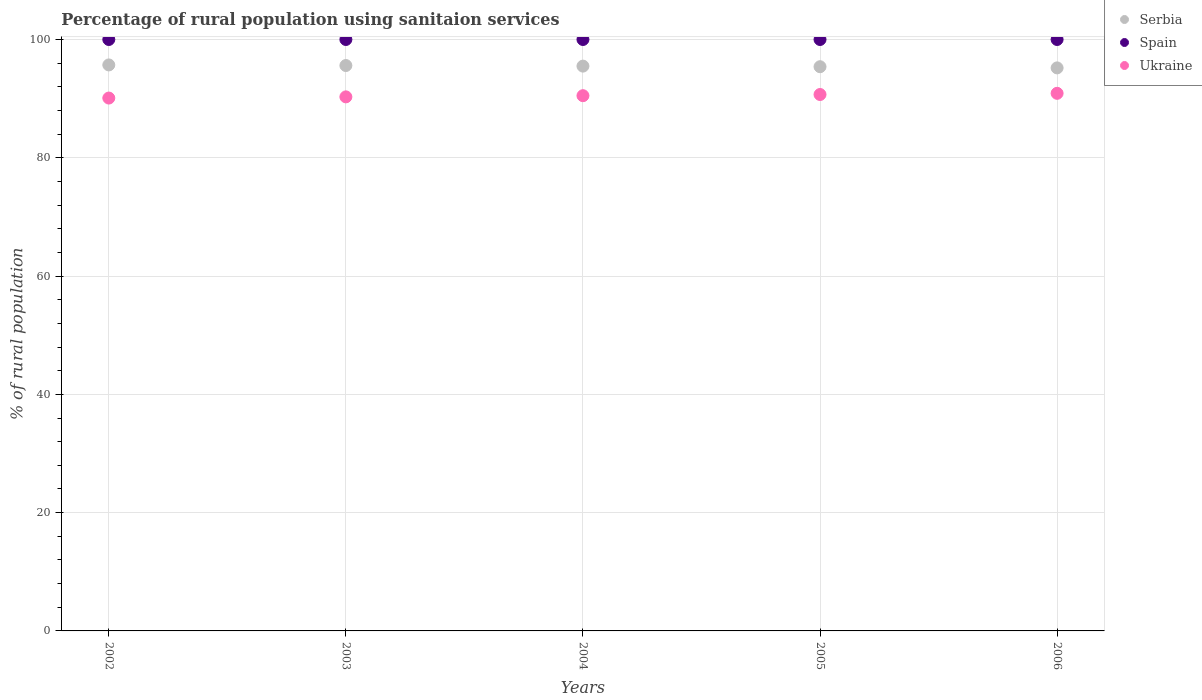How many different coloured dotlines are there?
Keep it short and to the point. 3. What is the percentage of rural population using sanitaion services in Ukraine in 2003?
Offer a terse response. 90.3. Across all years, what is the maximum percentage of rural population using sanitaion services in Ukraine?
Your response must be concise. 90.9. Across all years, what is the minimum percentage of rural population using sanitaion services in Spain?
Your answer should be very brief. 100. What is the total percentage of rural population using sanitaion services in Spain in the graph?
Make the answer very short. 500. What is the difference between the percentage of rural population using sanitaion services in Spain in 2002 and that in 2003?
Make the answer very short. 0. What is the difference between the percentage of rural population using sanitaion services in Serbia in 2006 and the percentage of rural population using sanitaion services in Spain in 2003?
Give a very brief answer. -4.8. What is the average percentage of rural population using sanitaion services in Serbia per year?
Provide a short and direct response. 95.48. In the year 2006, what is the difference between the percentage of rural population using sanitaion services in Serbia and percentage of rural population using sanitaion services in Ukraine?
Provide a short and direct response. 4.3. In how many years, is the percentage of rural population using sanitaion services in Spain greater than 56 %?
Give a very brief answer. 5. What is the ratio of the percentage of rural population using sanitaion services in Ukraine in 2004 to that in 2005?
Make the answer very short. 1. Is the percentage of rural population using sanitaion services in Ukraine in 2004 less than that in 2006?
Your response must be concise. Yes. What is the difference between the highest and the second highest percentage of rural population using sanitaion services in Ukraine?
Your answer should be very brief. 0.2. Is the sum of the percentage of rural population using sanitaion services in Serbia in 2003 and 2005 greater than the maximum percentage of rural population using sanitaion services in Spain across all years?
Make the answer very short. Yes. Is the percentage of rural population using sanitaion services in Spain strictly greater than the percentage of rural population using sanitaion services in Ukraine over the years?
Provide a short and direct response. Yes. How many dotlines are there?
Offer a terse response. 3. How many years are there in the graph?
Keep it short and to the point. 5. What is the difference between two consecutive major ticks on the Y-axis?
Your response must be concise. 20. Are the values on the major ticks of Y-axis written in scientific E-notation?
Give a very brief answer. No. Does the graph contain grids?
Ensure brevity in your answer.  Yes. How many legend labels are there?
Make the answer very short. 3. How are the legend labels stacked?
Offer a terse response. Vertical. What is the title of the graph?
Keep it short and to the point. Percentage of rural population using sanitaion services. Does "Slovenia" appear as one of the legend labels in the graph?
Offer a very short reply. No. What is the label or title of the Y-axis?
Your answer should be very brief. % of rural population. What is the % of rural population in Serbia in 2002?
Offer a terse response. 95.7. What is the % of rural population in Spain in 2002?
Offer a terse response. 100. What is the % of rural population in Ukraine in 2002?
Your answer should be compact. 90.1. What is the % of rural population in Serbia in 2003?
Give a very brief answer. 95.6. What is the % of rural population of Ukraine in 2003?
Give a very brief answer. 90.3. What is the % of rural population in Serbia in 2004?
Your answer should be compact. 95.5. What is the % of rural population in Spain in 2004?
Provide a succinct answer. 100. What is the % of rural population in Ukraine in 2004?
Offer a terse response. 90.5. What is the % of rural population of Serbia in 2005?
Offer a very short reply. 95.4. What is the % of rural population in Ukraine in 2005?
Your answer should be compact. 90.7. What is the % of rural population of Serbia in 2006?
Give a very brief answer. 95.2. What is the % of rural population in Spain in 2006?
Provide a short and direct response. 100. What is the % of rural population of Ukraine in 2006?
Make the answer very short. 90.9. Across all years, what is the maximum % of rural population of Serbia?
Offer a very short reply. 95.7. Across all years, what is the maximum % of rural population of Spain?
Give a very brief answer. 100. Across all years, what is the maximum % of rural population in Ukraine?
Your response must be concise. 90.9. Across all years, what is the minimum % of rural population in Serbia?
Make the answer very short. 95.2. Across all years, what is the minimum % of rural population in Spain?
Make the answer very short. 100. Across all years, what is the minimum % of rural population of Ukraine?
Your answer should be very brief. 90.1. What is the total % of rural population of Serbia in the graph?
Keep it short and to the point. 477.4. What is the total % of rural population of Spain in the graph?
Keep it short and to the point. 500. What is the total % of rural population in Ukraine in the graph?
Your answer should be compact. 452.5. What is the difference between the % of rural population in Spain in 2002 and that in 2003?
Offer a very short reply. 0. What is the difference between the % of rural population of Serbia in 2002 and that in 2004?
Your response must be concise. 0.2. What is the difference between the % of rural population of Spain in 2002 and that in 2004?
Your answer should be compact. 0. What is the difference between the % of rural population of Serbia in 2002 and that in 2006?
Provide a short and direct response. 0.5. What is the difference between the % of rural population in Ukraine in 2002 and that in 2006?
Your answer should be very brief. -0.8. What is the difference between the % of rural population of Spain in 2003 and that in 2004?
Give a very brief answer. 0. What is the difference between the % of rural population in Ukraine in 2003 and that in 2004?
Make the answer very short. -0.2. What is the difference between the % of rural population of Serbia in 2003 and that in 2005?
Provide a short and direct response. 0.2. What is the difference between the % of rural population of Spain in 2003 and that in 2005?
Your answer should be very brief. 0. What is the difference between the % of rural population of Spain in 2003 and that in 2006?
Give a very brief answer. 0. What is the difference between the % of rural population in Serbia in 2004 and that in 2005?
Your answer should be very brief. 0.1. What is the difference between the % of rural population of Spain in 2004 and that in 2005?
Your answer should be very brief. 0. What is the difference between the % of rural population in Ukraine in 2004 and that in 2005?
Give a very brief answer. -0.2. What is the difference between the % of rural population of Serbia in 2004 and that in 2006?
Offer a terse response. 0.3. What is the difference between the % of rural population in Ukraine in 2005 and that in 2006?
Your answer should be compact. -0.2. What is the difference between the % of rural population in Spain in 2002 and the % of rural population in Ukraine in 2003?
Offer a terse response. 9.7. What is the difference between the % of rural population of Spain in 2002 and the % of rural population of Ukraine in 2005?
Your answer should be compact. 9.3. What is the difference between the % of rural population in Serbia in 2002 and the % of rural population in Spain in 2006?
Give a very brief answer. -4.3. What is the difference between the % of rural population of Serbia in 2003 and the % of rural population of Spain in 2005?
Make the answer very short. -4.4. What is the difference between the % of rural population of Serbia in 2003 and the % of rural population of Spain in 2006?
Your response must be concise. -4.4. What is the difference between the % of rural population in Serbia in 2003 and the % of rural population in Ukraine in 2006?
Keep it short and to the point. 4.7. What is the difference between the % of rural population of Serbia in 2004 and the % of rural population of Spain in 2005?
Your answer should be very brief. -4.5. What is the difference between the % of rural population in Serbia in 2004 and the % of rural population in Ukraine in 2005?
Provide a short and direct response. 4.8. What is the difference between the % of rural population of Spain in 2004 and the % of rural population of Ukraine in 2005?
Your answer should be compact. 9.3. What is the difference between the % of rural population of Serbia in 2004 and the % of rural population of Spain in 2006?
Offer a very short reply. -4.5. What is the difference between the % of rural population of Serbia in 2005 and the % of rural population of Spain in 2006?
Make the answer very short. -4.6. What is the average % of rural population of Serbia per year?
Your answer should be compact. 95.48. What is the average % of rural population of Ukraine per year?
Your answer should be very brief. 90.5. In the year 2003, what is the difference between the % of rural population of Serbia and % of rural population of Ukraine?
Offer a terse response. 5.3. In the year 2005, what is the difference between the % of rural population of Serbia and % of rural population of Ukraine?
Keep it short and to the point. 4.7. In the year 2005, what is the difference between the % of rural population of Spain and % of rural population of Ukraine?
Provide a succinct answer. 9.3. In the year 2006, what is the difference between the % of rural population of Serbia and % of rural population of Spain?
Give a very brief answer. -4.8. In the year 2006, what is the difference between the % of rural population in Serbia and % of rural population in Ukraine?
Provide a succinct answer. 4.3. In the year 2006, what is the difference between the % of rural population in Spain and % of rural population in Ukraine?
Ensure brevity in your answer.  9.1. What is the ratio of the % of rural population of Spain in 2002 to that in 2003?
Provide a short and direct response. 1. What is the ratio of the % of rural population of Ukraine in 2002 to that in 2003?
Offer a very short reply. 1. What is the ratio of the % of rural population in Spain in 2002 to that in 2004?
Offer a very short reply. 1. What is the ratio of the % of rural population of Ukraine in 2002 to that in 2004?
Provide a succinct answer. 1. What is the ratio of the % of rural population of Serbia in 2002 to that in 2005?
Your answer should be very brief. 1. What is the ratio of the % of rural population in Ukraine in 2002 to that in 2005?
Provide a succinct answer. 0.99. What is the ratio of the % of rural population in Serbia in 2002 to that in 2006?
Your response must be concise. 1.01. What is the ratio of the % of rural population in Spain in 2002 to that in 2006?
Provide a succinct answer. 1. What is the ratio of the % of rural population of Serbia in 2003 to that in 2004?
Your answer should be very brief. 1. What is the ratio of the % of rural population in Ukraine in 2003 to that in 2004?
Provide a succinct answer. 1. What is the ratio of the % of rural population in Serbia in 2003 to that in 2005?
Provide a succinct answer. 1. What is the ratio of the % of rural population of Spain in 2003 to that in 2005?
Provide a short and direct response. 1. What is the ratio of the % of rural population of Serbia in 2004 to that in 2005?
Ensure brevity in your answer.  1. What is the ratio of the % of rural population in Spain in 2004 to that in 2005?
Make the answer very short. 1. What is the ratio of the % of rural population of Ukraine in 2004 to that in 2005?
Give a very brief answer. 1. What is the ratio of the % of rural population in Serbia in 2004 to that in 2006?
Keep it short and to the point. 1. What is the difference between the highest and the second highest % of rural population in Serbia?
Provide a short and direct response. 0.1. What is the difference between the highest and the lowest % of rural population in Serbia?
Your answer should be very brief. 0.5. 